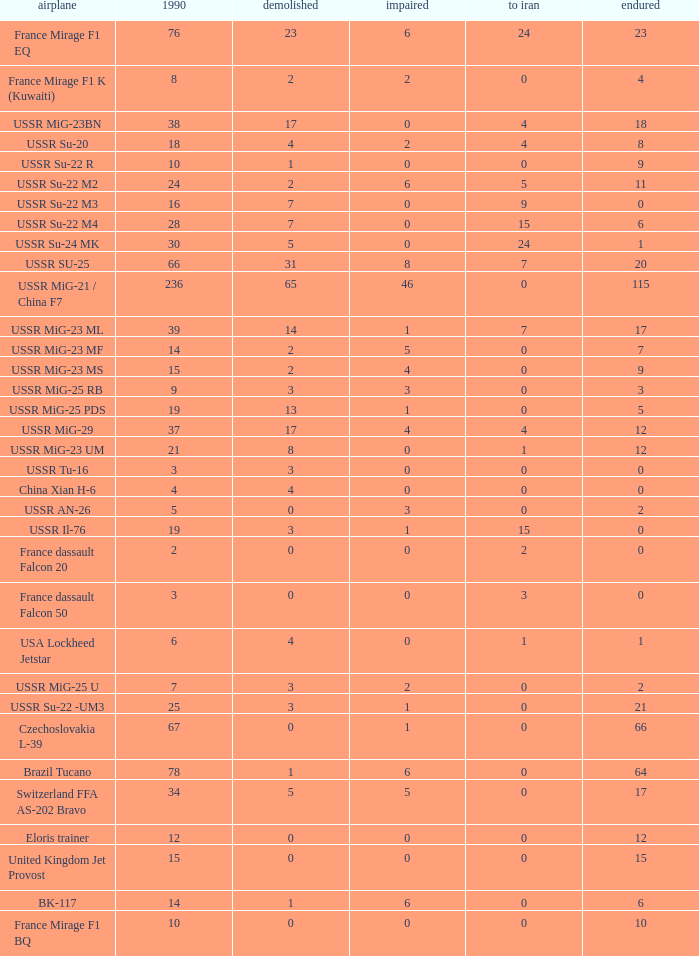If there were 14 in 1990 and 6 survived how many were destroyed? 1.0. Can you parse all the data within this table? {'header': ['airplane', '1990', 'demolished', 'impaired', 'to iran', 'endured'], 'rows': [['France Mirage F1 EQ', '76', '23', '6', '24', '23'], ['France Mirage F1 K (Kuwaiti)', '8', '2', '2', '0', '4'], ['USSR MiG-23BN', '38', '17', '0', '4', '18'], ['USSR Su-20', '18', '4', '2', '4', '8'], ['USSR Su-22 R', '10', '1', '0', '0', '9'], ['USSR Su-22 M2', '24', '2', '6', '5', '11'], ['USSR Su-22 M3', '16', '7', '0', '9', '0'], ['USSR Su-22 M4', '28', '7', '0', '15', '6'], ['USSR Su-24 MK', '30', '5', '0', '24', '1'], ['USSR SU-25', '66', '31', '8', '7', '20'], ['USSR MiG-21 / China F7', '236', '65', '46', '0', '115'], ['USSR MiG-23 ML', '39', '14', '1', '7', '17'], ['USSR MiG-23 MF', '14', '2', '5', '0', '7'], ['USSR MiG-23 MS', '15', '2', '4', '0', '9'], ['USSR MiG-25 RB', '9', '3', '3', '0', '3'], ['USSR MiG-25 PDS', '19', '13', '1', '0', '5'], ['USSR MiG-29', '37', '17', '4', '4', '12'], ['USSR MiG-23 UM', '21', '8', '0', '1', '12'], ['USSR Tu-16', '3', '3', '0', '0', '0'], ['China Xian H-6', '4', '4', '0', '0', '0'], ['USSR AN-26', '5', '0', '3', '0', '2'], ['USSR Il-76', '19', '3', '1', '15', '0'], ['France dassault Falcon 20', '2', '0', '0', '2', '0'], ['France dassault Falcon 50', '3', '0', '0', '3', '0'], ['USA Lockheed Jetstar', '6', '4', '0', '1', '1'], ['USSR MiG-25 U', '7', '3', '2', '0', '2'], ['USSR Su-22 -UM3', '25', '3', '1', '0', '21'], ['Czechoslovakia L-39', '67', '0', '1', '0', '66'], ['Brazil Tucano', '78', '1', '6', '0', '64'], ['Switzerland FFA AS-202 Bravo', '34', '5', '5', '0', '17'], ['Eloris trainer', '12', '0', '0', '0', '12'], ['United Kingdom Jet Provost', '15', '0', '0', '0', '15'], ['BK-117', '14', '1', '6', '0', '6'], ['France Mirage F1 BQ', '10', '0', '0', '0', '10']]} 